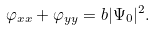<formula> <loc_0><loc_0><loc_500><loc_500>\varphi _ { x x } + \varphi _ { y y } = b | \Psi _ { 0 } | ^ { 2 } .</formula> 